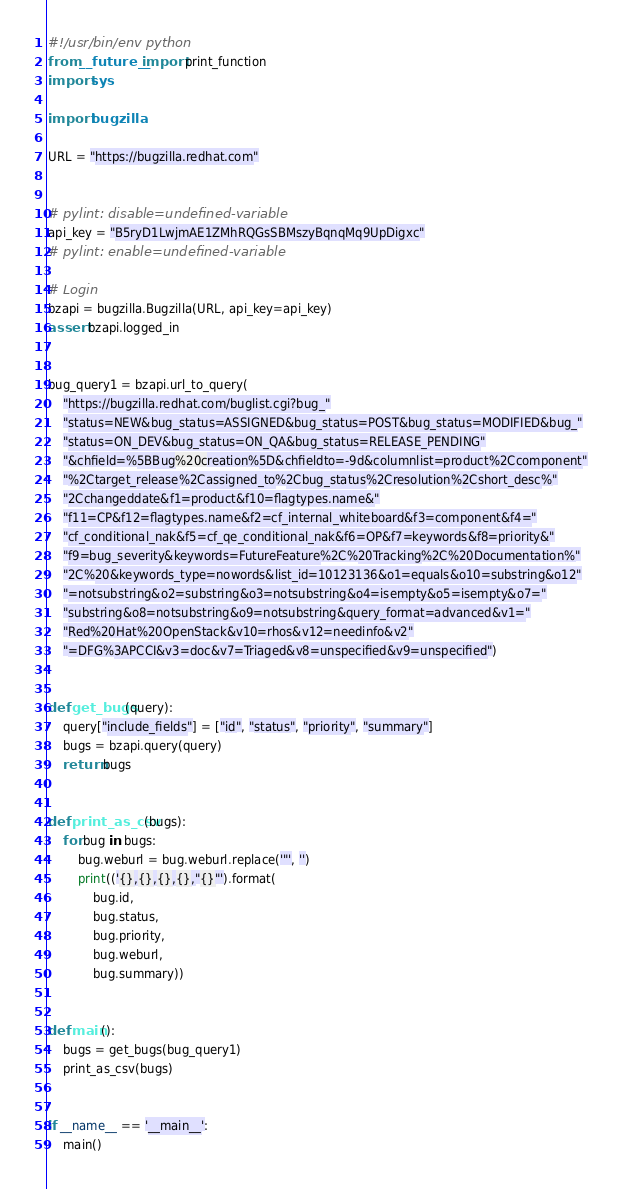<code> <loc_0><loc_0><loc_500><loc_500><_Python_>#!/usr/bin/env python
from __future__ import print_function
import sys

import bugzilla

URL = "https://bugzilla.redhat.com"


# pylint: disable=undefined-variable
api_key = "B5ryD1LwjmAE1ZMhRQGsSBMszyBqnqMq9UpDigxc"
# pylint: enable=undefined-variable

# Login
bzapi = bugzilla.Bugzilla(URL, api_key=api_key)
assert bzapi.logged_in


bug_query1 = bzapi.url_to_query(
    "https://bugzilla.redhat.com/buglist.cgi?bug_"
    "status=NEW&bug_status=ASSIGNED&bug_status=POST&bug_status=MODIFIED&bug_"
    "status=ON_DEV&bug_status=ON_QA&bug_status=RELEASE_PENDING"
    "&chfield=%5BBug%20creation%5D&chfieldto=-9d&columnlist=product%2Ccomponent"
    "%2Ctarget_release%2Cassigned_to%2Cbug_status%2Cresolution%2Cshort_desc%"
    "2Cchangeddate&f1=product&f10=flagtypes.name&"
    "f11=CP&f12=flagtypes.name&f2=cf_internal_whiteboard&f3=component&f4="
    "cf_conditional_nak&f5=cf_qe_conditional_nak&f6=OP&f7=keywords&f8=priority&"
    "f9=bug_severity&keywords=FutureFeature%2C%20Tracking%2C%20Documentation%"
    "2C%20&keywords_type=nowords&list_id=10123136&o1=equals&o10=substring&o12"
    "=notsubstring&o2=substring&o3=notsubstring&o4=isempty&o5=isempty&o7="
    "substring&o8=notsubstring&o9=notsubstring&query_format=advanced&v1="
    "Red%20Hat%20OpenStack&v10=rhos&v12=needinfo&v2"
    "=DFG%3APCCI&v3=doc&v7=Triaged&v8=unspecified&v9=unspecified")


def get_bugs(query):
    query["include_fields"] = ["id", "status", "priority", "summary"]
    bugs = bzapi.query(query)
    return bugs


def print_as_csv(bugs):
    for bug in bugs:
        bug.weburl = bug.weburl.replace('"', '')
        print(('{},{},{},{},"{}"').format(
            bug.id,
            bug.status,
            bug.priority,
            bug.weburl,
            bug.summary))


def main():
    bugs = get_bugs(bug_query1)
    print_as_csv(bugs)


if __name__ == '__main__':
    main()
</code> 